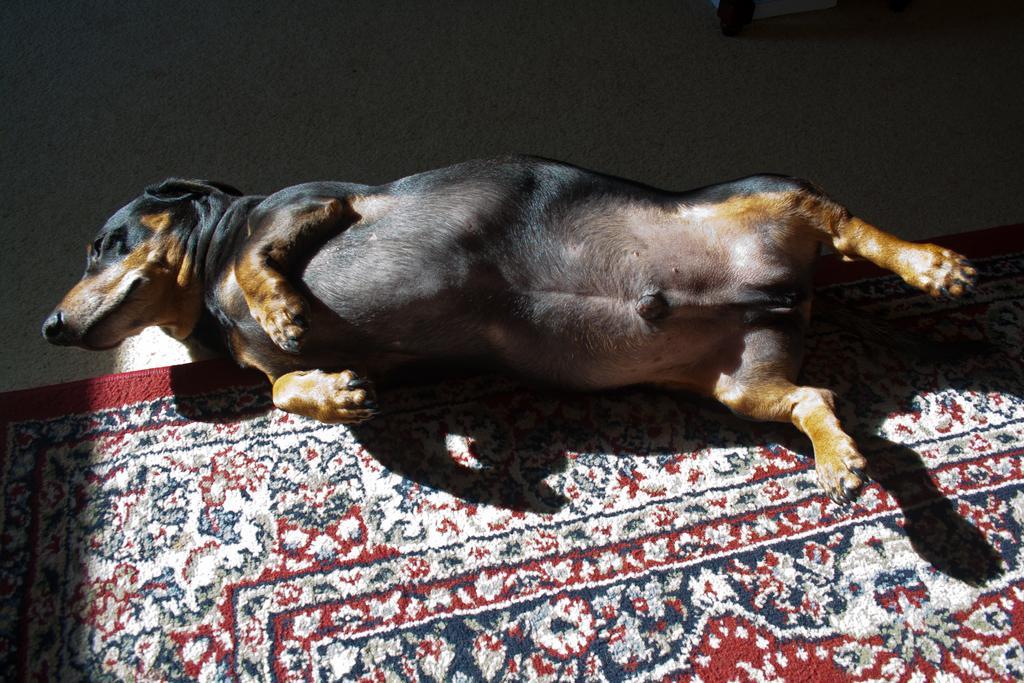Describe this image in one or two sentences. This is the picture of a dog which is laying on the floor mat. 